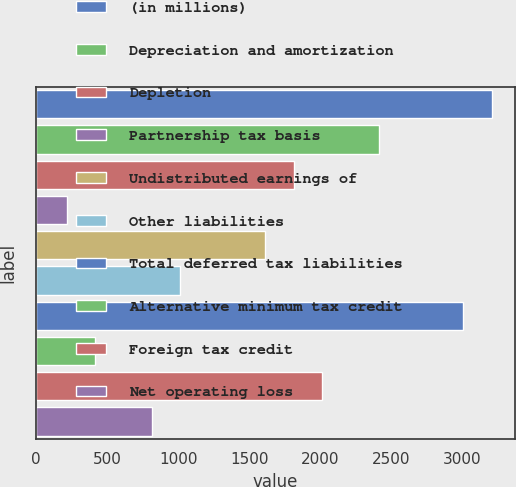<chart> <loc_0><loc_0><loc_500><loc_500><bar_chart><fcel>(in millions)<fcel>Depreciation and amortization<fcel>Depletion<fcel>Partnership tax basis<fcel>Undistributed earnings of<fcel>Other liabilities<fcel>Total deferred tax liabilities<fcel>Alternative minimum tax credit<fcel>Foreign tax credit<fcel>Net operating loss<nl><fcel>3210.54<fcel>2412.18<fcel>1813.41<fcel>216.69<fcel>1613.82<fcel>1015.05<fcel>3010.95<fcel>416.28<fcel>2013<fcel>815.46<nl></chart> 